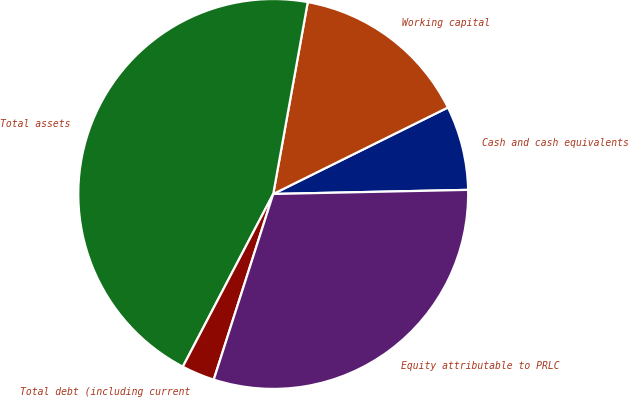Convert chart. <chart><loc_0><loc_0><loc_500><loc_500><pie_chart><fcel>Cash and cash equivalents<fcel>Working capital<fcel>Total assets<fcel>Total debt (including current<fcel>Equity attributable to PRLC<nl><fcel>6.98%<fcel>14.85%<fcel>45.16%<fcel>2.74%<fcel>30.27%<nl></chart> 